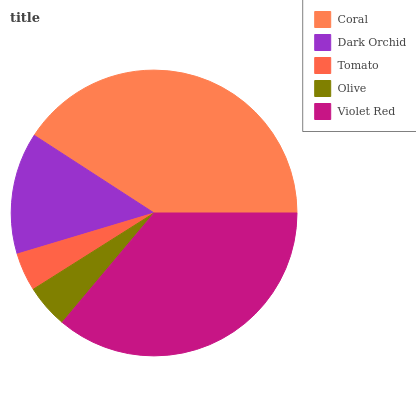Is Tomato the minimum?
Answer yes or no. Yes. Is Coral the maximum?
Answer yes or no. Yes. Is Dark Orchid the minimum?
Answer yes or no. No. Is Dark Orchid the maximum?
Answer yes or no. No. Is Coral greater than Dark Orchid?
Answer yes or no. Yes. Is Dark Orchid less than Coral?
Answer yes or no. Yes. Is Dark Orchid greater than Coral?
Answer yes or no. No. Is Coral less than Dark Orchid?
Answer yes or no. No. Is Dark Orchid the high median?
Answer yes or no. Yes. Is Dark Orchid the low median?
Answer yes or no. Yes. Is Coral the high median?
Answer yes or no. No. Is Olive the low median?
Answer yes or no. No. 